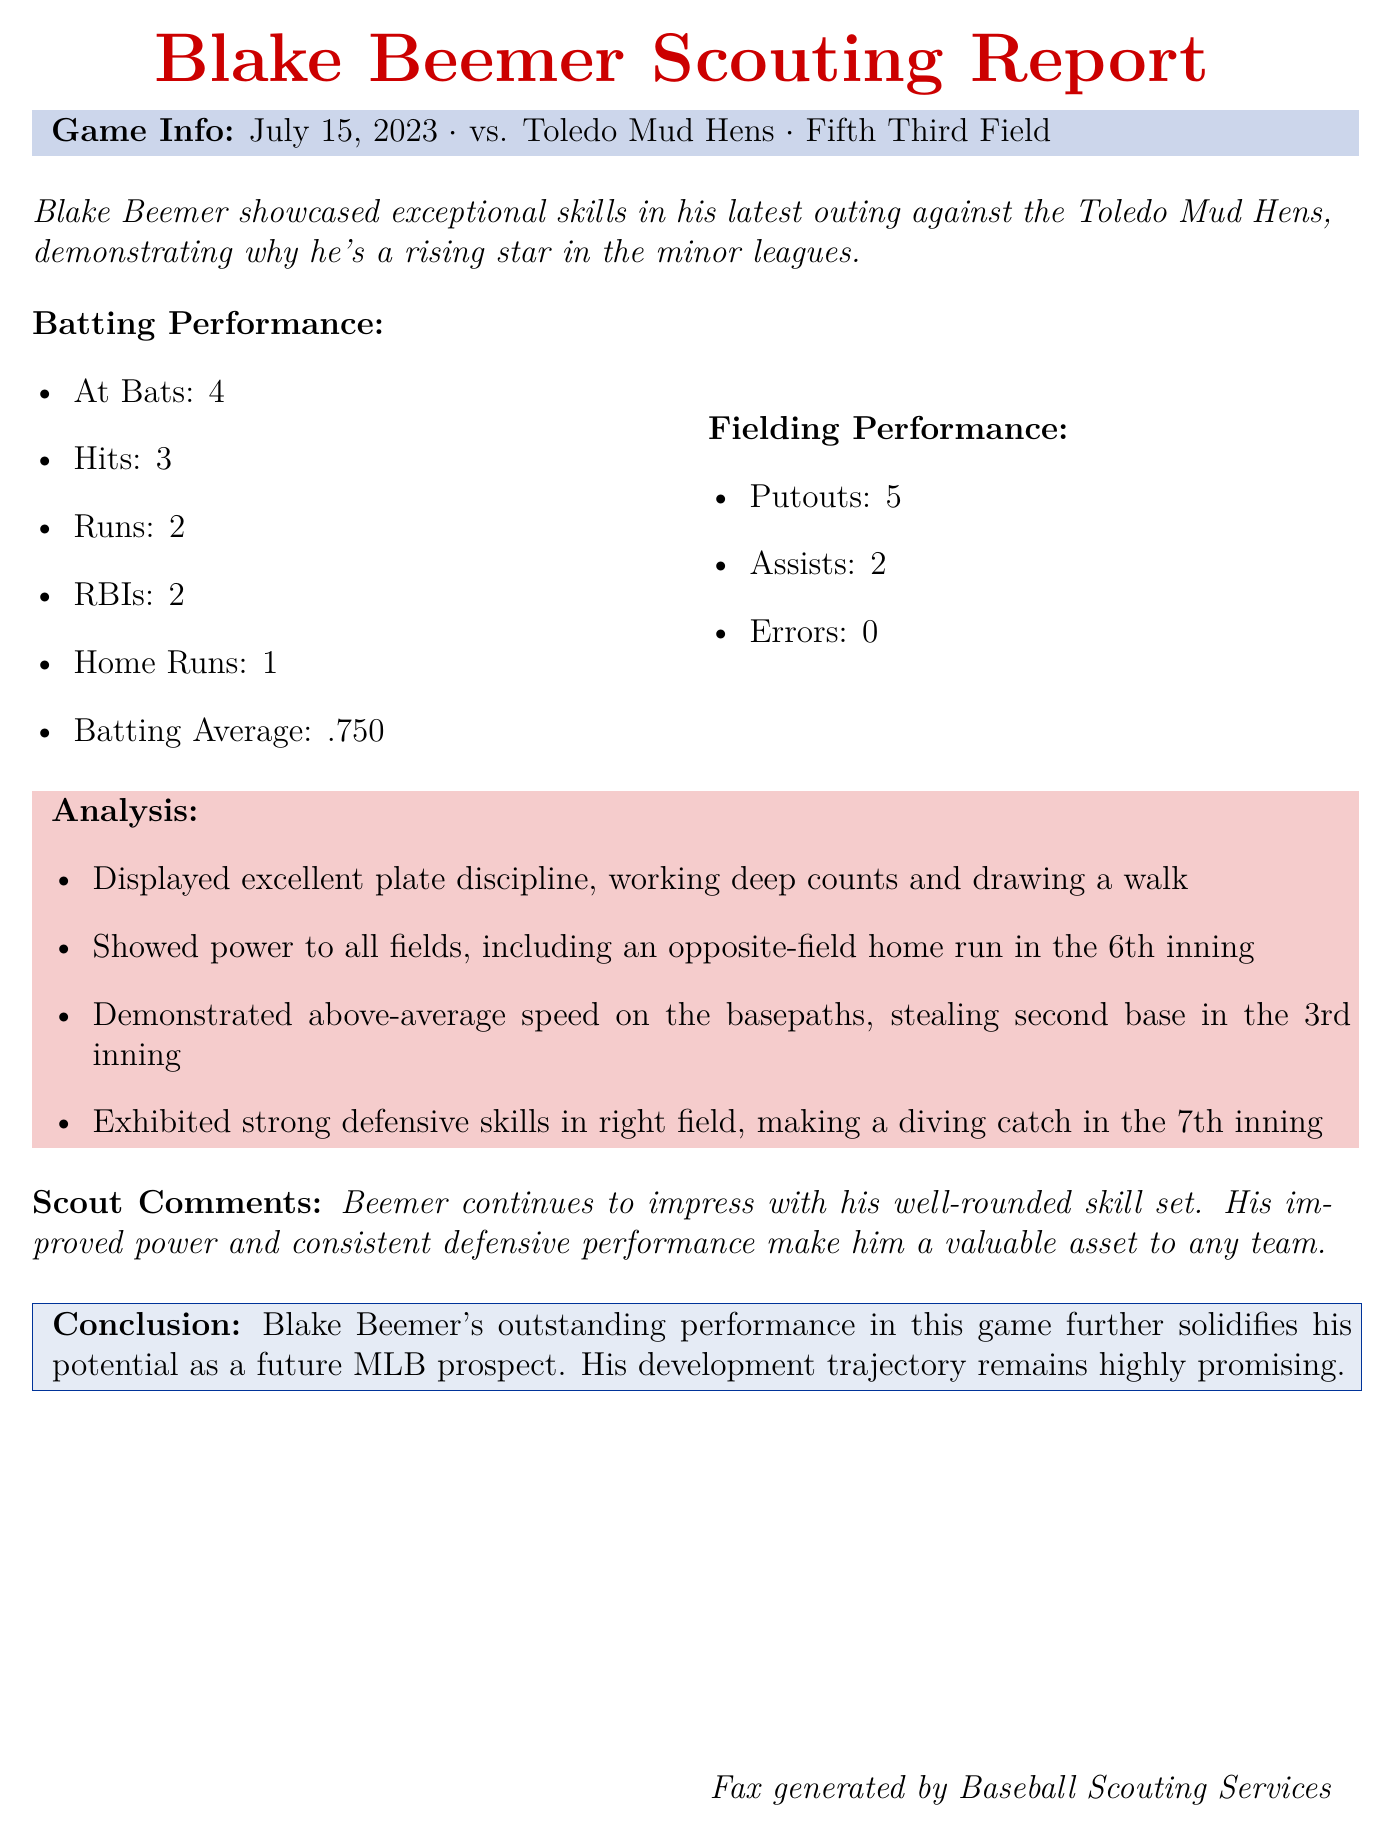What date did Blake Beemer play his latest game? The game was played on July 15, 2023, against the Toledo Mud Hens.
Answer: July 15, 2023 How many hits did Beemer achieve in the game? The document states that Beemer had 3 hits in the game.
Answer: 3 What was Blake Beemer's batting average in this game? His batting average for the game is mentioned as .750.
Answer: .750 How many runs did Beemer score? The report indicates that he scored 2 runs during this game.
Answer: 2 What notable play did Beemer make in the field? He made a diving catch in the 7th inning, which is highlighted in the analysis.
Answer: Diving catch What statistical category did Beemer receive 2 in? The stats indicate that he had 2 assists in the fielding performance.
Answer: Assists In which inning did Beemer hit a home run? The document notes he hit a home run in the 6th inning of the game.
Answer: 6th inning What specific skill does the scout comment on regarding Beemer? The scout comments on Beemer's well-rounded skill set and improved power.
Answer: Well-rounded skill set What overall conclusion does the scout make about Beemer's future? The conclusion states that Beemer's performance solidifies his potential as a future MLB prospect.
Answer: Future MLB prospect 